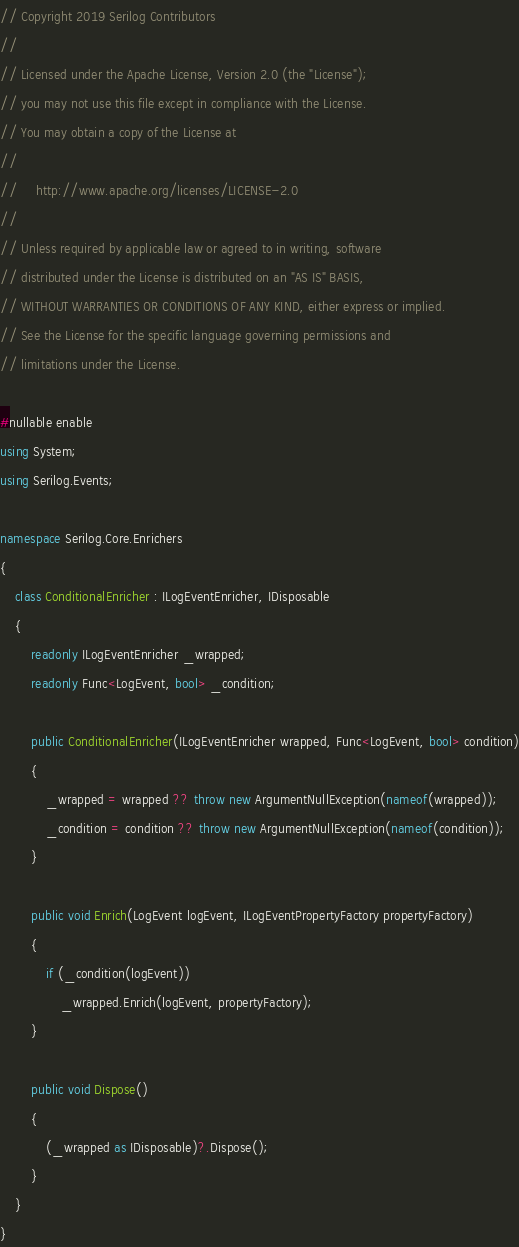Convert code to text. <code><loc_0><loc_0><loc_500><loc_500><_C#_>// Copyright 2019 Serilog Contributors
//
// Licensed under the Apache License, Version 2.0 (the "License");
// you may not use this file except in compliance with the License.
// You may obtain a copy of the License at
//
//     http://www.apache.org/licenses/LICENSE-2.0
//
// Unless required by applicable law or agreed to in writing, software
// distributed under the License is distributed on an "AS IS" BASIS,
// WITHOUT WARRANTIES OR CONDITIONS OF ANY KIND, either express or implied.
// See the License for the specific language governing permissions and
// limitations under the License.

#nullable enable
using System;
using Serilog.Events;

namespace Serilog.Core.Enrichers
{
    class ConditionalEnricher : ILogEventEnricher, IDisposable
    {
        readonly ILogEventEnricher _wrapped;
        readonly Func<LogEvent, bool> _condition;

        public ConditionalEnricher(ILogEventEnricher wrapped, Func<LogEvent, bool> condition)
        {
            _wrapped = wrapped ?? throw new ArgumentNullException(nameof(wrapped));
            _condition = condition ?? throw new ArgumentNullException(nameof(condition));
        }

        public void Enrich(LogEvent logEvent, ILogEventPropertyFactory propertyFactory)
        {
            if (_condition(logEvent))
                _wrapped.Enrich(logEvent, propertyFactory);
        }

        public void Dispose()
        {
            (_wrapped as IDisposable)?.Dispose();
        }
    }
}
</code> 